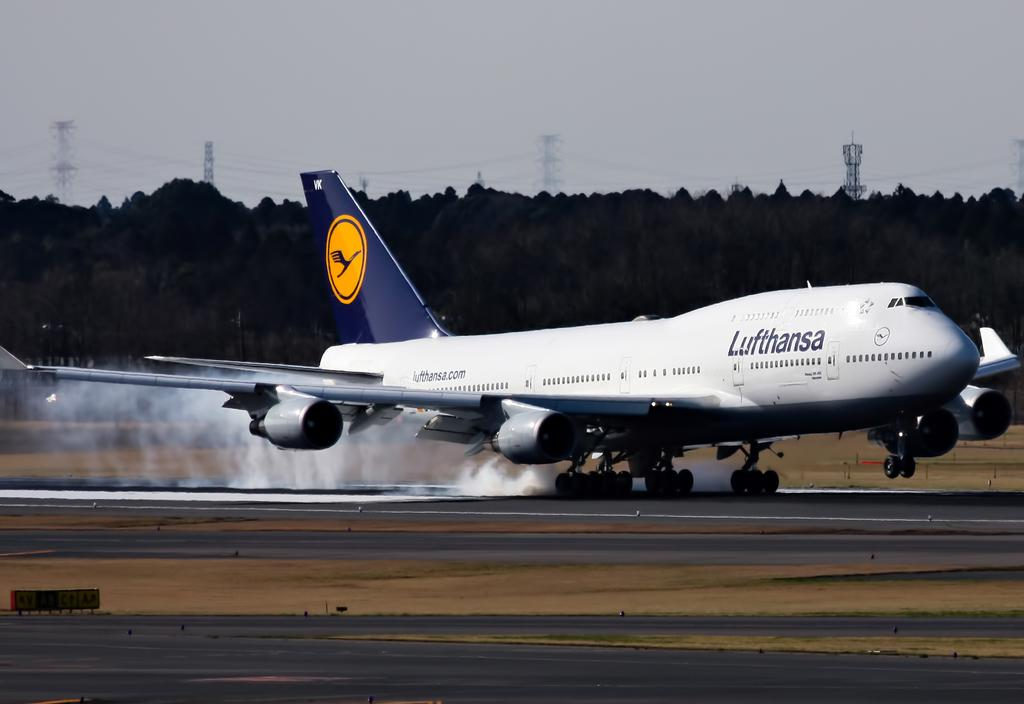<image>
Share a concise interpretation of the image provided. A commercial airplane has smoke coming out of the back of the plane. 